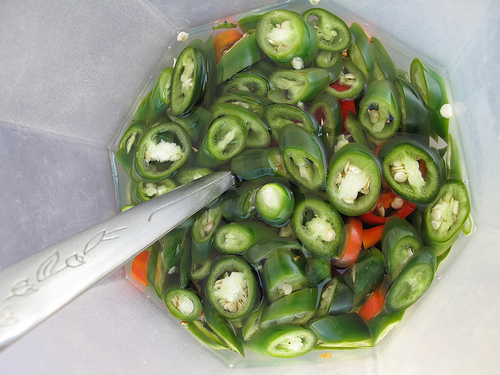<image>
Is the jalapeno under the spoon? No. The jalapeno is not positioned under the spoon. The vertical relationship between these objects is different. 